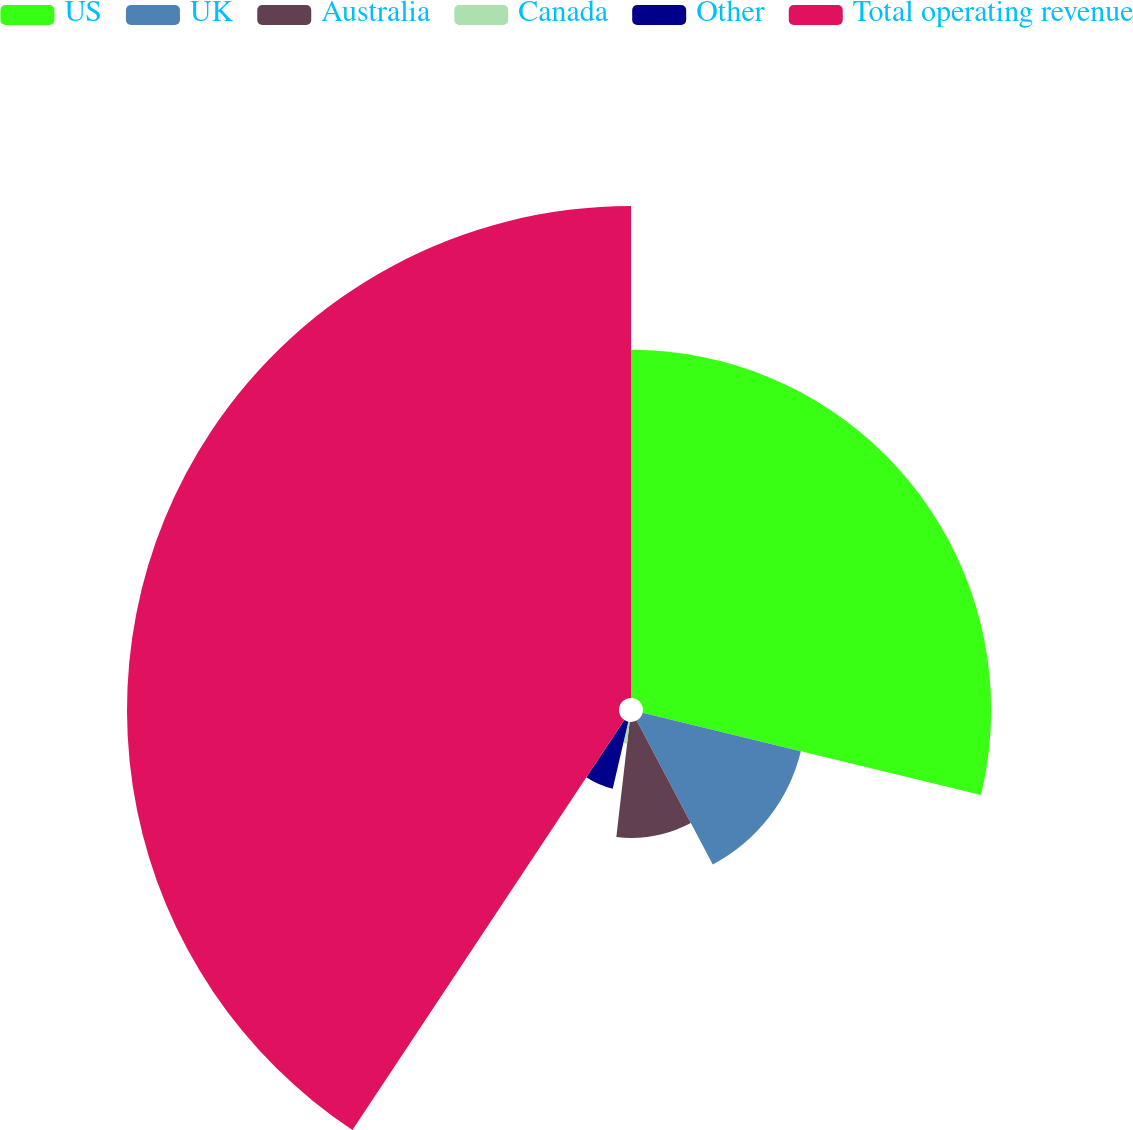Convert chart to OTSL. <chart><loc_0><loc_0><loc_500><loc_500><pie_chart><fcel>US<fcel>UK<fcel>Australia<fcel>Canada<fcel>Other<fcel>Total operating revenue<nl><fcel>28.79%<fcel>13.46%<fcel>9.58%<fcel>1.8%<fcel>5.69%<fcel>40.68%<nl></chart> 